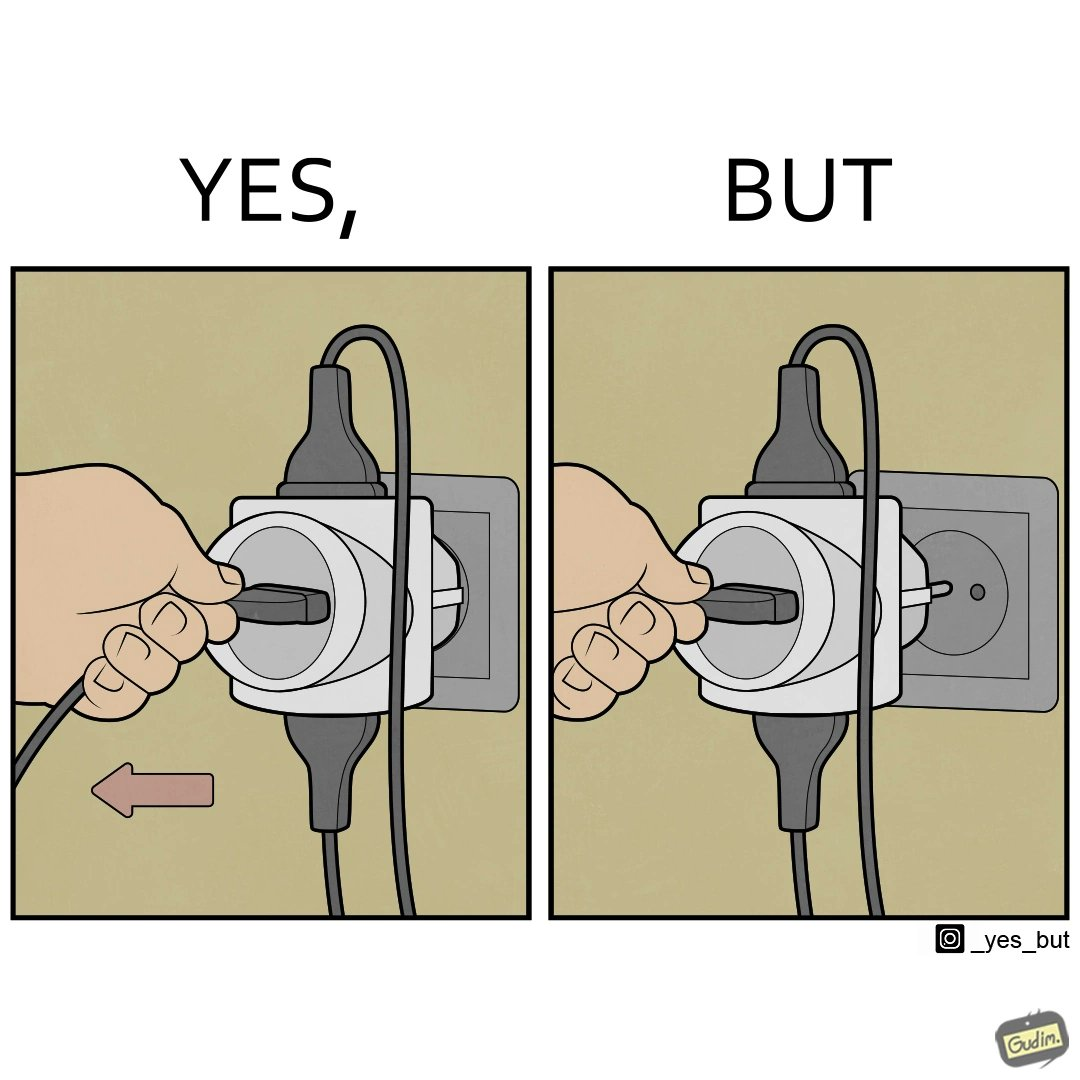Does this image contain satire or humor? Yes, this image is satirical. 